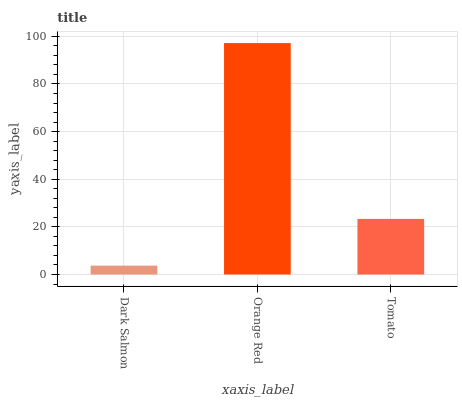Is Dark Salmon the minimum?
Answer yes or no. Yes. Is Orange Red the maximum?
Answer yes or no. Yes. Is Tomato the minimum?
Answer yes or no. No. Is Tomato the maximum?
Answer yes or no. No. Is Orange Red greater than Tomato?
Answer yes or no. Yes. Is Tomato less than Orange Red?
Answer yes or no. Yes. Is Tomato greater than Orange Red?
Answer yes or no. No. Is Orange Red less than Tomato?
Answer yes or no. No. Is Tomato the high median?
Answer yes or no. Yes. Is Tomato the low median?
Answer yes or no. Yes. Is Orange Red the high median?
Answer yes or no. No. Is Dark Salmon the low median?
Answer yes or no. No. 